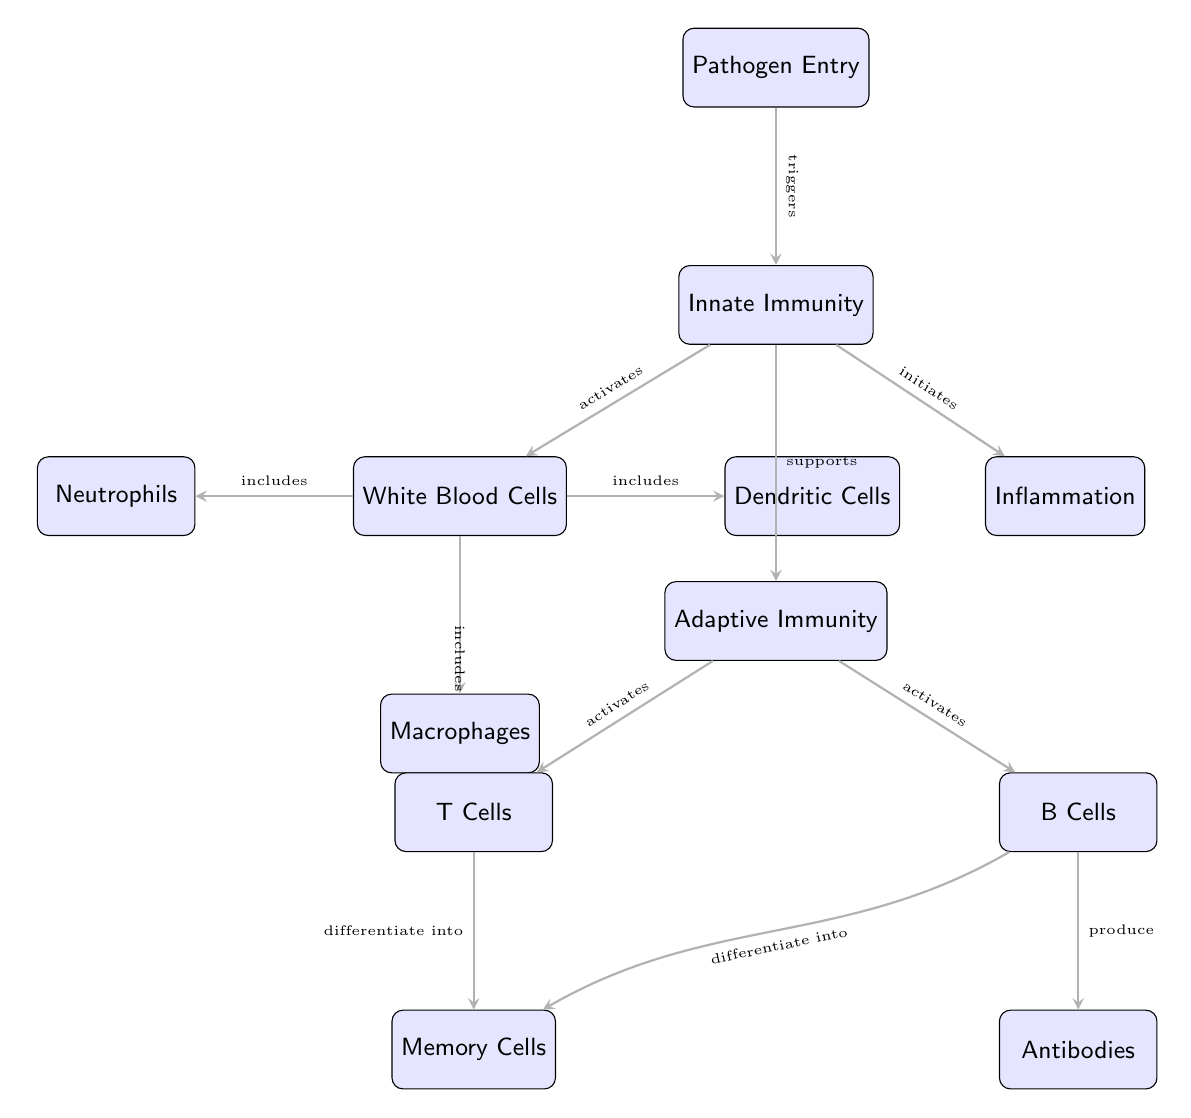What triggers the innate immunity in the diagram? The innate immunity is triggered by the "Pathogen Entry," which is indicated as the initial node in the diagram. The arrow shows that upon pathogen entry, the innate immune response is activated.
Answer: Pathogen Entry How many types of white blood cells are represented in the diagram? The diagram includes three types of white blood cells: Neutrophils, Macrophages, and Dendritic Cells. Each type is connected under the White Blood Cells node.
Answer: Three What role do B Cells play in the adaptive immunity response? B Cells are shown to produce Antibodies, as indicated by the directed edge in the diagram; this relationship is crucial to the immune response by creating specific antibodies against pathogens.
Answer: Produce Antibodies How does innate immunity support adaptive immunity? The diagram states that innate immunity "supports" adaptive immunity, indicating a functional relationship where the activation of innate mechanisms aids the effectiveness of adaptive responses.
Answer: Supports What cells do T Cells differentiate into according to the diagram? The diagram indicates that T Cells differentiate into Memory Cells, connected with a directed edge that shows this developmental pathway following T Cell activation in the adaptive response.
Answer: Memory Cells What is the connection between innate immunity and inflammation? The diagram specifies that innate immunity "initiates" inflammation, demonstrating the role of innate responses in the inflammatory process that occurs in response to pathogens.
Answer: Initiates 